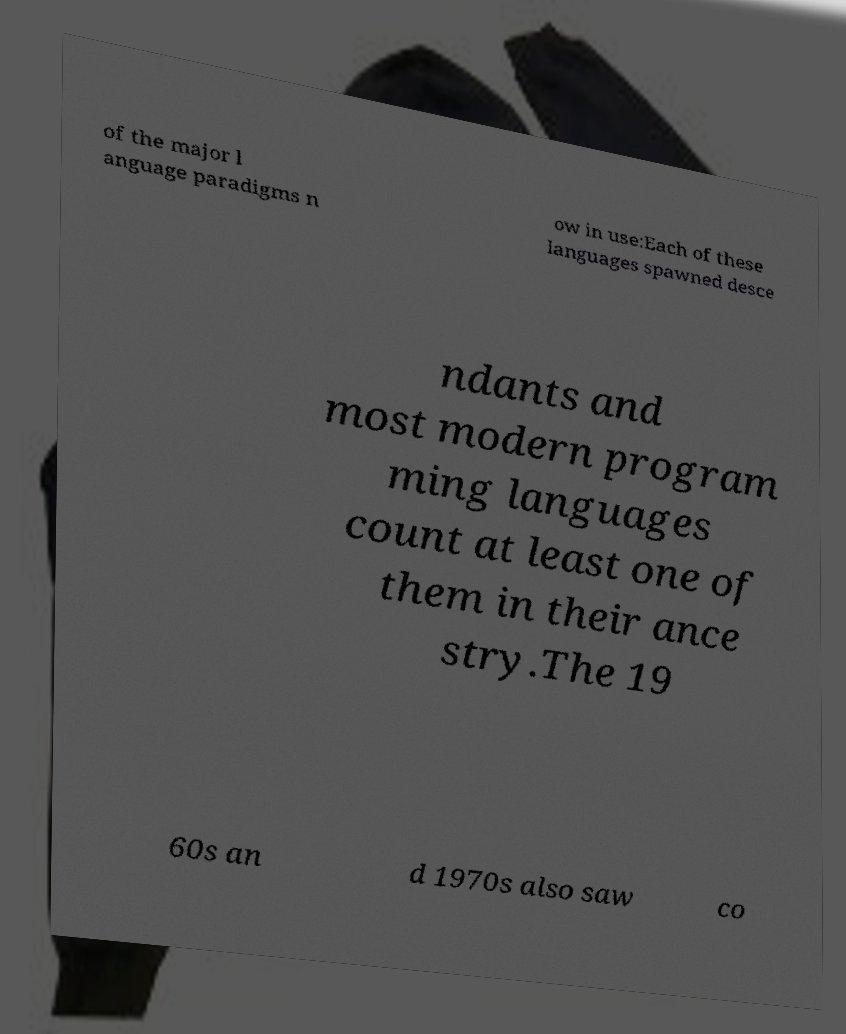There's text embedded in this image that I need extracted. Can you transcribe it verbatim? of the major l anguage paradigms n ow in use:Each of these languages spawned desce ndants and most modern program ming languages count at least one of them in their ance stry.The 19 60s an d 1970s also saw co 